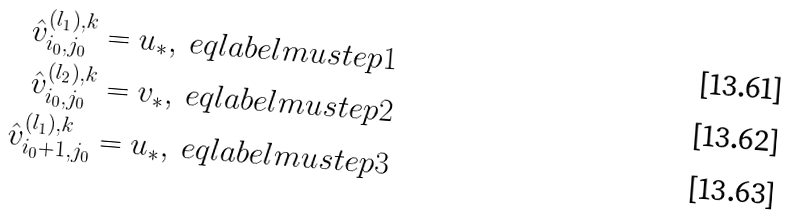<formula> <loc_0><loc_0><loc_500><loc_500>\hat { v } ^ { ( l _ { 1 } ) , k } _ { i _ { 0 } , j _ { 0 } } = u _ { * } , \ e q l a b e l { m u s t e p 1 } \\ \hat { v } ^ { ( l _ { 2 } ) , k } _ { i _ { 0 } , j _ { 0 } } = v _ { * } , \ e q l a b e l { m u s t e p 2 } \\ \hat { v } ^ { ( l _ { 1 } ) , k } _ { i _ { 0 } + 1 , j _ { 0 } } = u _ { * } , \ e q l a b e l { m u s t e p 3 }</formula> 